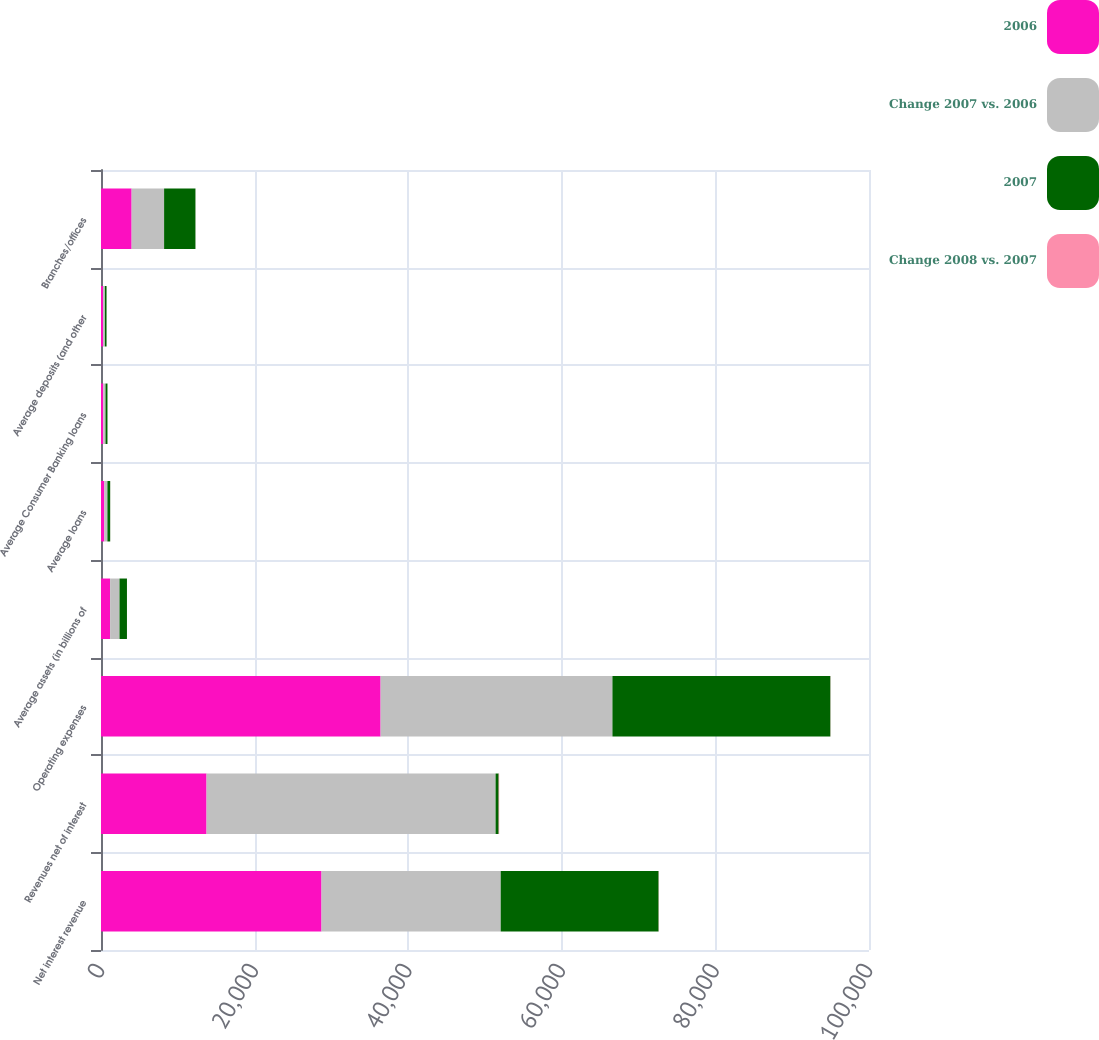Convert chart. <chart><loc_0><loc_0><loc_500><loc_500><stacked_bar_chart><ecel><fcel>Net interest revenue<fcel>Revenues net of interest<fcel>Operating expenses<fcel>Average assets (in billions of<fcel>Average loans<fcel>Average Consumer Banking loans<fcel>Average deposits (and other<fcel>Branches/offices<nl><fcel>2006<fcel>28713<fcel>13744<fcel>36407<fcel>1188<fcel>429.7<fcel>298.2<fcel>261.6<fcel>3989<nl><fcel>Change 2007 vs. 2006<fcel>23333<fcel>37634<fcel>30186<fcel>1222<fcel>405.2<fcel>289.8<fcel>245.1<fcel>4227<nl><fcel>2007<fcel>20557<fcel>405.2<fcel>28380<fcel>971<fcel>363.1<fcel>255<fcel>218.1<fcel>4084<nl><fcel>Change 2008 vs. 2007<fcel>23<fcel>63<fcel>21<fcel>3<fcel>6<fcel>3<fcel>7<fcel>6<nl></chart> 